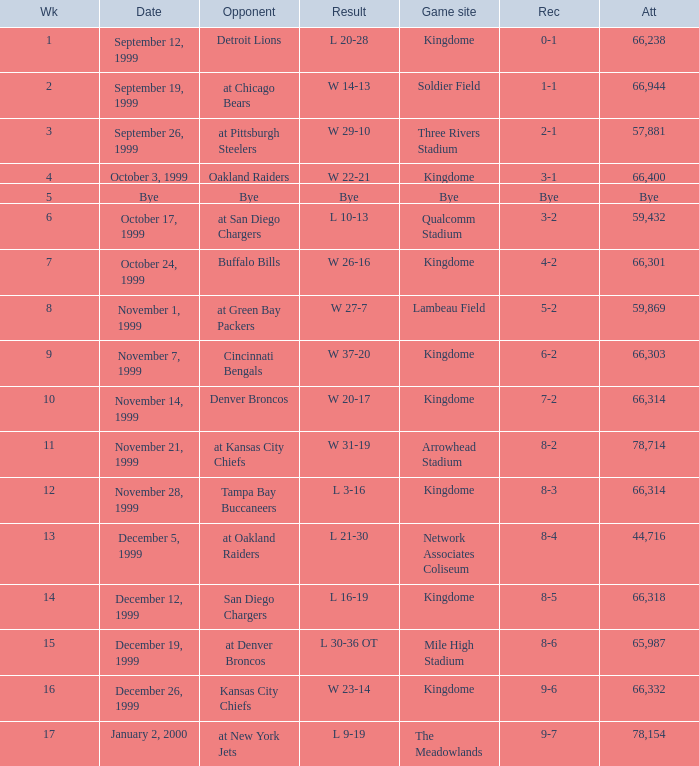For the game that was played on week 2, what is the record? 1-1. 